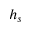Convert formula to latex. <formula><loc_0><loc_0><loc_500><loc_500>h _ { s }</formula> 